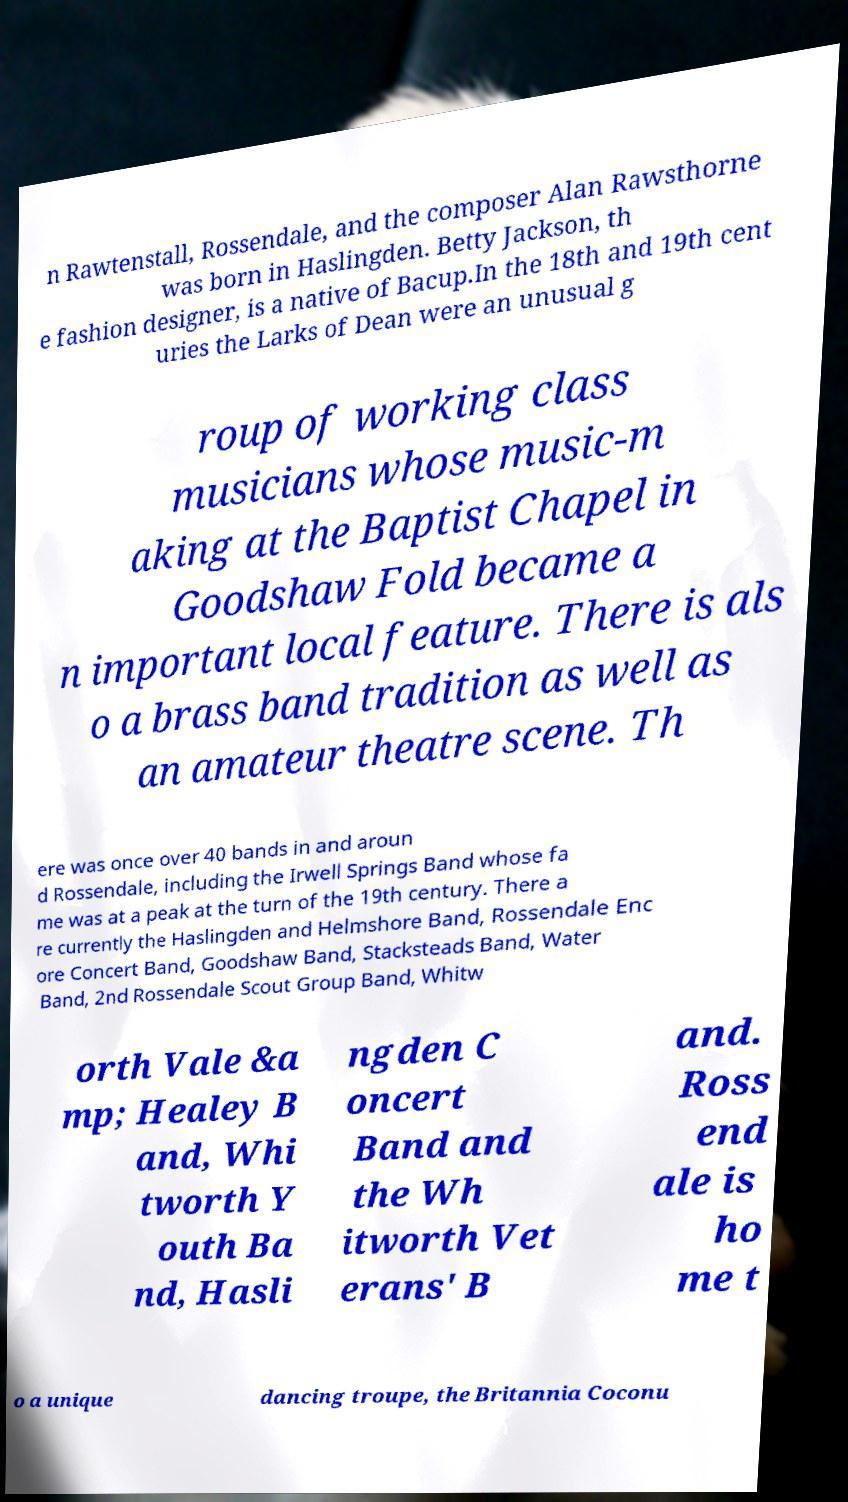For documentation purposes, I need the text within this image transcribed. Could you provide that? n Rawtenstall, Rossendale, and the composer Alan Rawsthorne was born in Haslingden. Betty Jackson, th e fashion designer, is a native of Bacup.In the 18th and 19th cent uries the Larks of Dean were an unusual g roup of working class musicians whose music-m aking at the Baptist Chapel in Goodshaw Fold became a n important local feature. There is als o a brass band tradition as well as an amateur theatre scene. Th ere was once over 40 bands in and aroun d Rossendale, including the Irwell Springs Band whose fa me was at a peak at the turn of the 19th century. There a re currently the Haslingden and Helmshore Band, Rossendale Enc ore Concert Band, Goodshaw Band, Stacksteads Band, Water Band, 2nd Rossendale Scout Group Band, Whitw orth Vale &a mp; Healey B and, Whi tworth Y outh Ba nd, Hasli ngden C oncert Band and the Wh itworth Vet erans' B and. Ross end ale is ho me t o a unique dancing troupe, the Britannia Coconu 